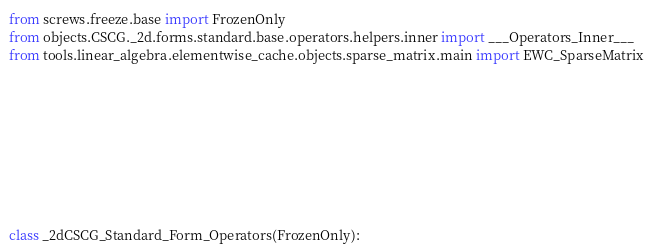<code> <loc_0><loc_0><loc_500><loc_500><_Python_>



from screws.freeze.base import FrozenOnly
from objects.CSCG._2d.forms.standard.base.operators.helpers.inner import ___Operators_Inner___
from tools.linear_algebra.elementwise_cache.objects.sparse_matrix.main import EWC_SparseMatrix









class _2dCSCG_Standard_Form_Operators(FrozenOnly):</code> 